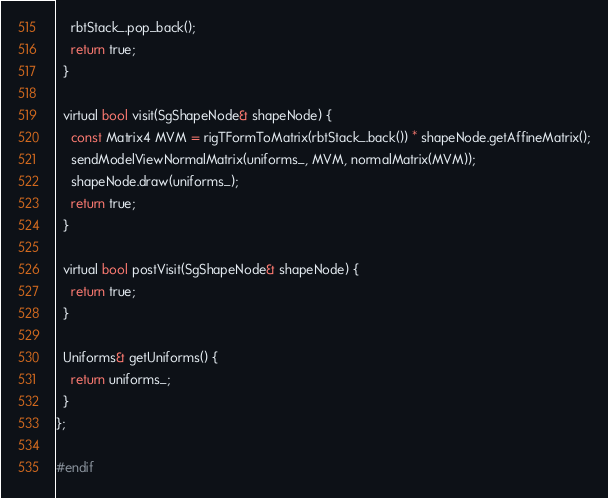Convert code to text. <code><loc_0><loc_0><loc_500><loc_500><_C_>    rbtStack_.pop_back();
    return true;
  }

  virtual bool visit(SgShapeNode& shapeNode) {
    const Matrix4 MVM = rigTFormToMatrix(rbtStack_.back()) * shapeNode.getAffineMatrix();
    sendModelViewNormalMatrix(uniforms_, MVM, normalMatrix(MVM));
    shapeNode.draw(uniforms_);
    return true;
  }

  virtual bool postVisit(SgShapeNode& shapeNode) {
    return true;
  }

  Uniforms& getUniforms() {
    return uniforms_;
  }
};

#endif



</code> 